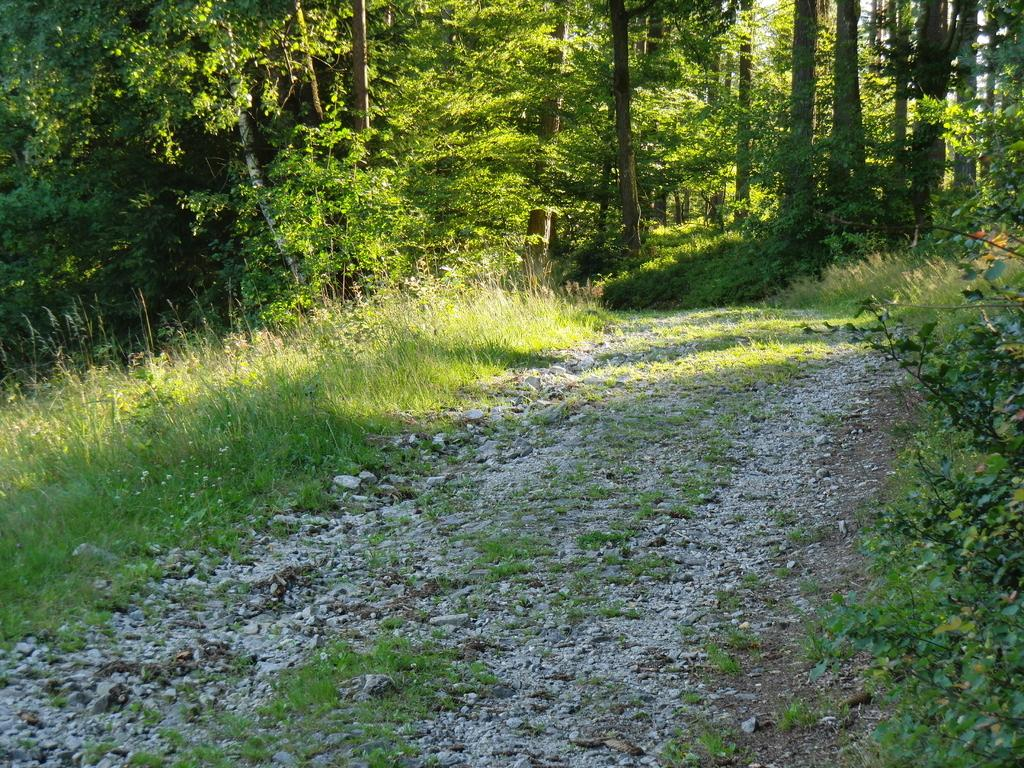What type of surface is visible on the path in the image? There is grass and rocks on the path in the image. What can be seen in the background of the image? There are plants and trees in the background of the image. Where is the cannon located in the image? There is no cannon present in the image. What type of vegetable can be seen growing in the wilderness in the image? There is no wilderness or vegetable present in the image. 